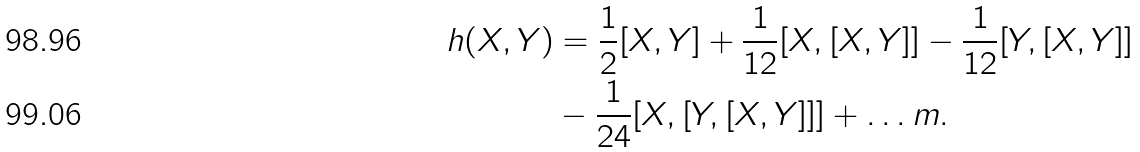Convert formula to latex. <formula><loc_0><loc_0><loc_500><loc_500>h ( X , Y ) & = \frac { 1 } { 2 } [ X , Y ] + \frac { 1 } { 1 2 } [ X , [ X , Y ] ] - \frac { 1 } { 1 2 } [ Y , [ X , Y ] ] \\ & - \frac { 1 } { 2 4 } [ X , [ Y , [ X , Y ] ] ] + \dots m .</formula> 